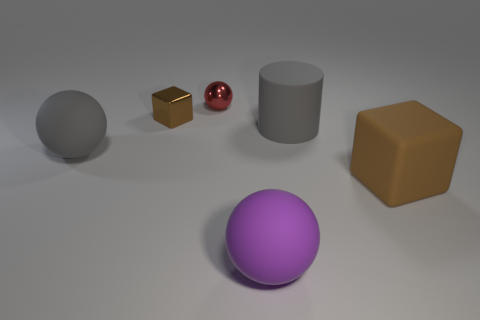Are there any gray balls that are to the left of the gray thing to the left of the large purple rubber ball?
Ensure brevity in your answer.  No. What material is the other object that is the same shape as the brown shiny thing?
Make the answer very short. Rubber. Are there more tiny cubes behind the red metallic thing than tiny red objects that are right of the big purple sphere?
Make the answer very short. No. There is a brown thing that is made of the same material as the purple object; what is its shape?
Your answer should be compact. Cube. Is the number of brown rubber objects to the left of the cylinder greater than the number of big matte things?
Ensure brevity in your answer.  No. How many big cylinders are the same color as the large block?
Your response must be concise. 0. What number of other things are there of the same color as the tiny shiny ball?
Make the answer very short. 0. Is the number of metallic things greater than the number of small brown things?
Offer a very short reply. Yes. What is the cylinder made of?
Offer a very short reply. Rubber. There is a ball that is left of the red thing; does it have the same size as the small brown metallic thing?
Make the answer very short. No. 